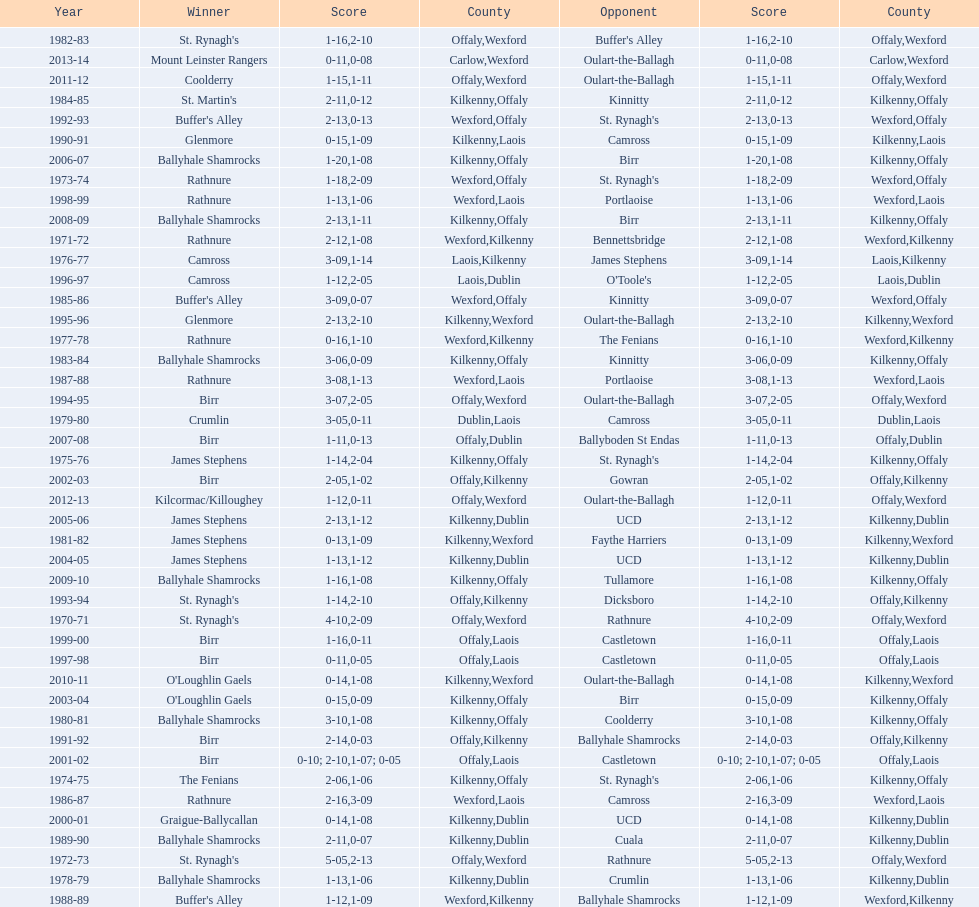What was the last season the leinster senior club hurling championships was won by a score differential of less than 11? 2007-08. 